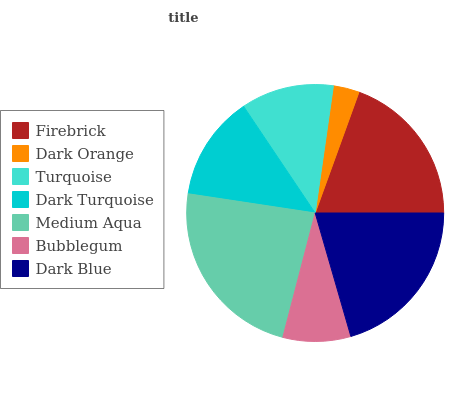Is Dark Orange the minimum?
Answer yes or no. Yes. Is Medium Aqua the maximum?
Answer yes or no. Yes. Is Turquoise the minimum?
Answer yes or no. No. Is Turquoise the maximum?
Answer yes or no. No. Is Turquoise greater than Dark Orange?
Answer yes or no. Yes. Is Dark Orange less than Turquoise?
Answer yes or no. Yes. Is Dark Orange greater than Turquoise?
Answer yes or no. No. Is Turquoise less than Dark Orange?
Answer yes or no. No. Is Dark Turquoise the high median?
Answer yes or no. Yes. Is Dark Turquoise the low median?
Answer yes or no. Yes. Is Dark Blue the high median?
Answer yes or no. No. Is Dark Orange the low median?
Answer yes or no. No. 